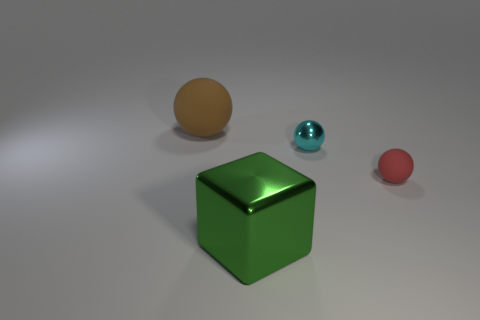Add 2 red balls. How many objects exist? 6 Subtract all cubes. How many objects are left? 3 Add 3 large green blocks. How many large green blocks exist? 4 Subtract 0 cyan cylinders. How many objects are left? 4 Subtract all green metallic objects. Subtract all small rubber spheres. How many objects are left? 2 Add 4 tiny cyan metallic spheres. How many tiny cyan metallic spheres are left? 5 